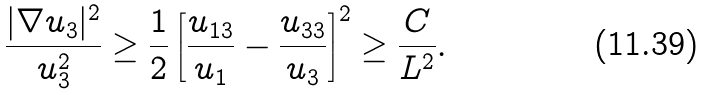Convert formula to latex. <formula><loc_0><loc_0><loc_500><loc_500>\frac { | \nabla u _ { 3 } | ^ { 2 } } { u _ { 3 } ^ { 2 } } \geq \frac { 1 } { 2 } \left [ \frac { u _ { 1 3 } } { u _ { 1 } } - \frac { u _ { 3 3 } } { u _ { 3 } } \right ] ^ { 2 } \geq \frac { C } { L ^ { 2 } } .</formula> 